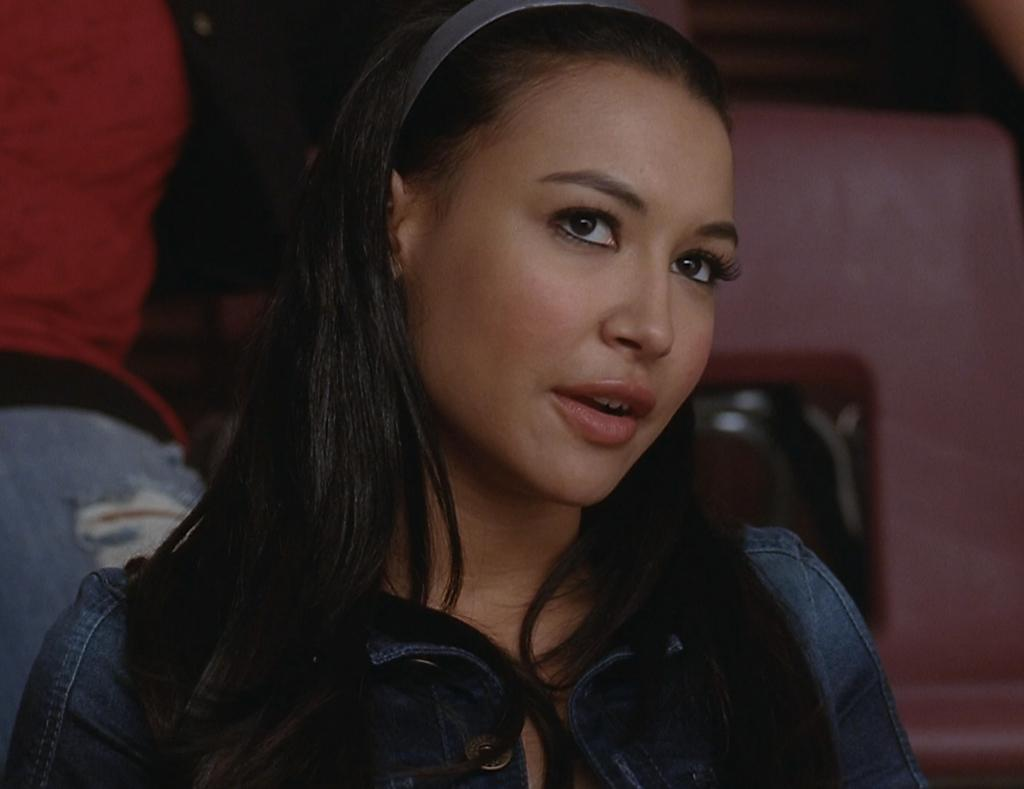Who is present in the image? There is a girl and another person in the image. What is the girl wearing in the image? The girl is wearing a shirt and a hair band. What is the other person wearing in the image? The other person is wearing a t-shirt and jeans. What can be seen on the right side of the image? There is a chair on the right side of the image. What type of cough does the governor have in the image? There is no mention of a governor or a cough in the image; it features a girl and another person. 